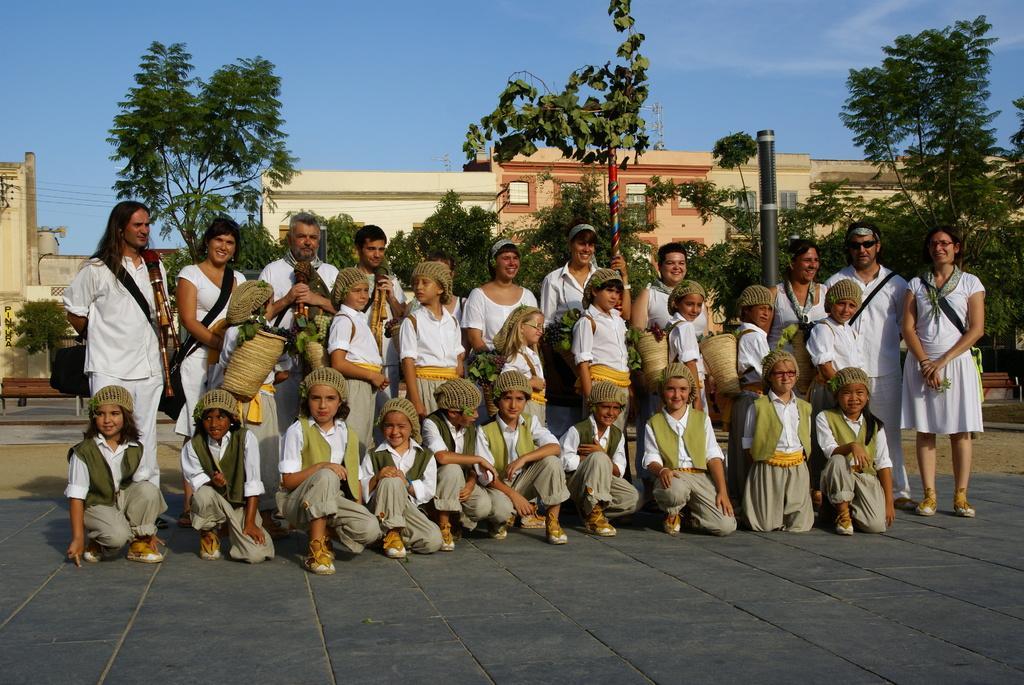Please provide a concise description of this image. In this picture we can see some men and women standing, wearing a white shirt and looking to the camera. In the front bottom side we can see some small girls sitting on the ground and giving a pose to the camera. Behind there is a brown building and some trees. On the top there is a sky. 